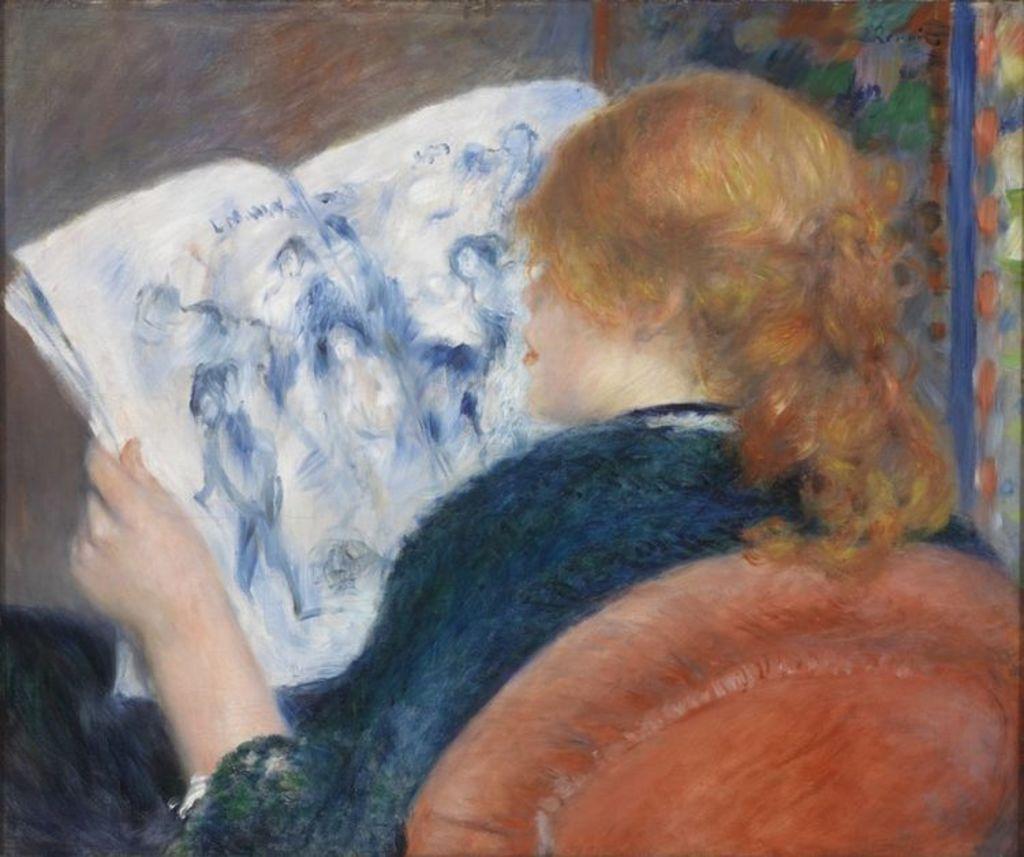Can you describe this image briefly? In this picture we can see a painting, in this painting we can see a person is sitting on a chair and holding a book. 